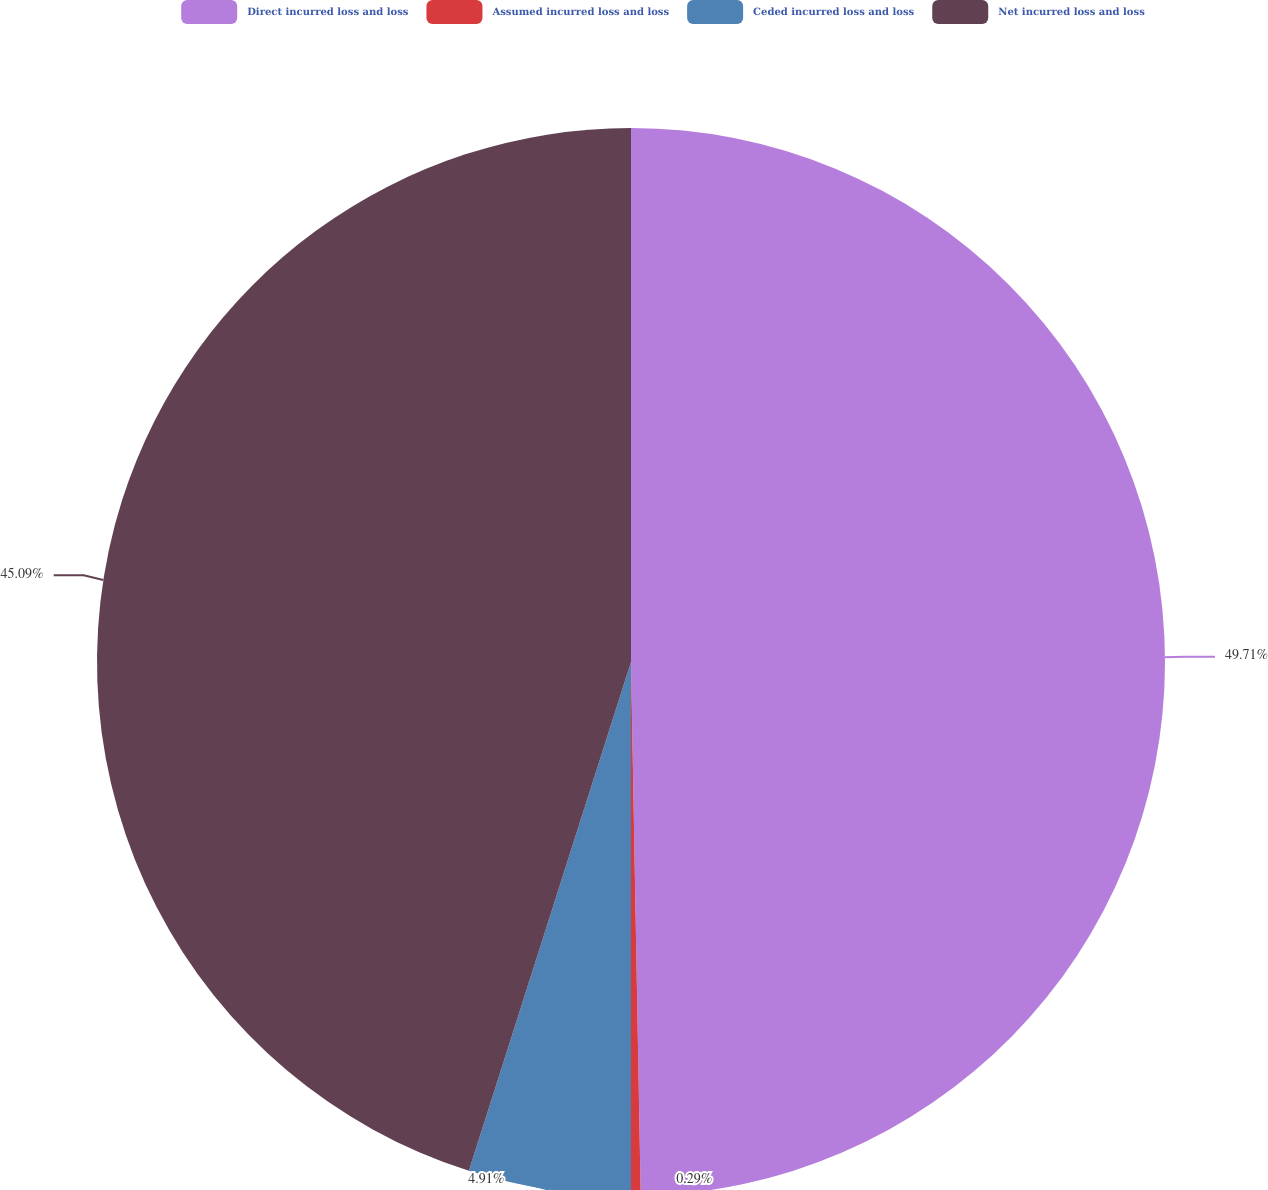<chart> <loc_0><loc_0><loc_500><loc_500><pie_chart><fcel>Direct incurred loss and loss<fcel>Assumed incurred loss and loss<fcel>Ceded incurred loss and loss<fcel>Net incurred loss and loss<nl><fcel>49.71%<fcel>0.29%<fcel>4.91%<fcel>45.09%<nl></chart> 